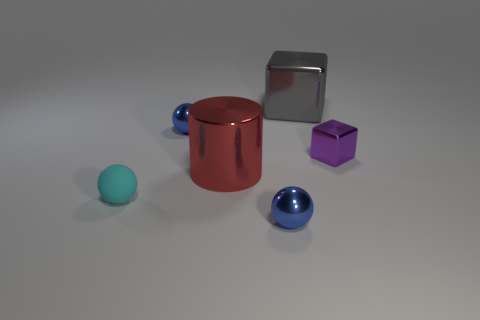There is another big metallic object that is the same shape as the purple thing; what color is it?
Give a very brief answer. Gray. How many tiny purple shiny things have the same shape as the gray metal thing?
Offer a terse response. 1. How many cyan rubber things are there?
Your answer should be compact. 1. Are there any small green blocks that have the same material as the large red thing?
Keep it short and to the point. No. Does the blue sphere behind the cyan matte object have the same size as the blue metal object that is in front of the rubber ball?
Provide a short and direct response. Yes. There is a blue shiny ball that is behind the tiny purple thing; what is its size?
Make the answer very short. Small. Is there a big shiny object of the same color as the large shiny cylinder?
Ensure brevity in your answer.  No. There is a large metallic object that is in front of the large gray metallic object; are there any big gray metallic blocks left of it?
Provide a short and direct response. No. There is a purple metal block; is it the same size as the blue metal ball that is in front of the large red object?
Ensure brevity in your answer.  Yes. There is a tiny metallic thing right of the small blue object to the right of the red cylinder; are there any cyan matte spheres that are behind it?
Make the answer very short. No. 